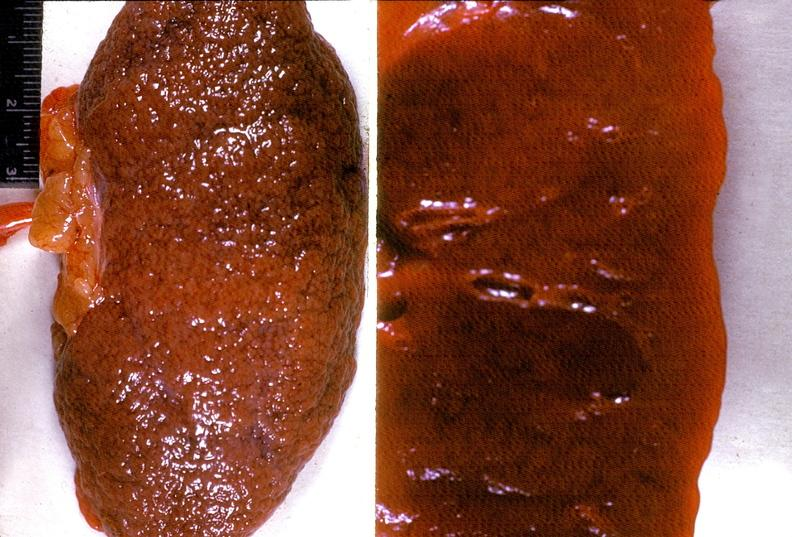where is this?
Answer the question using a single word or phrase. Urinary 